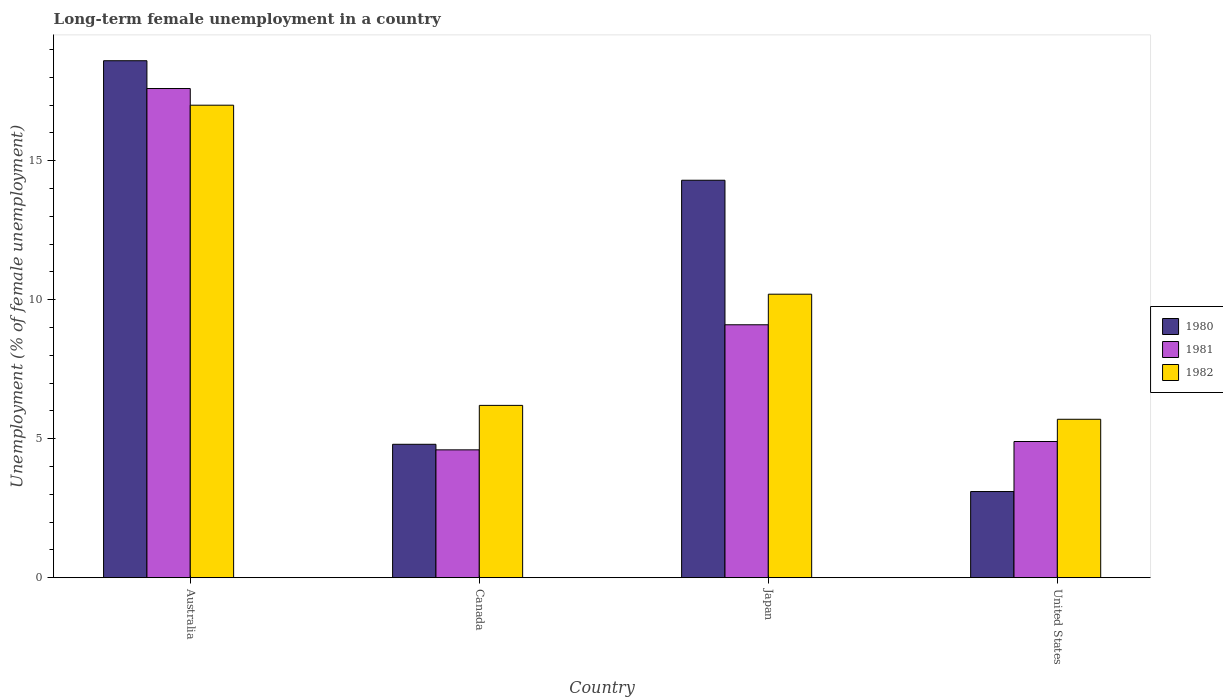How many different coloured bars are there?
Offer a terse response. 3. Are the number of bars on each tick of the X-axis equal?
Make the answer very short. Yes. How many bars are there on the 3rd tick from the right?
Offer a very short reply. 3. What is the label of the 1st group of bars from the left?
Keep it short and to the point. Australia. In how many cases, is the number of bars for a given country not equal to the number of legend labels?
Ensure brevity in your answer.  0. What is the percentage of long-term unemployed female population in 1981 in United States?
Your answer should be compact. 4.9. Across all countries, what is the maximum percentage of long-term unemployed female population in 1981?
Your answer should be very brief. 17.6. Across all countries, what is the minimum percentage of long-term unemployed female population in 1981?
Provide a succinct answer. 4.6. In which country was the percentage of long-term unemployed female population in 1982 minimum?
Your response must be concise. United States. What is the total percentage of long-term unemployed female population in 1982 in the graph?
Give a very brief answer. 39.1. What is the difference between the percentage of long-term unemployed female population in 1982 in Australia and that in Canada?
Your answer should be very brief. 10.8. What is the difference between the percentage of long-term unemployed female population in 1981 in United States and the percentage of long-term unemployed female population in 1982 in Canada?
Offer a very short reply. -1.3. What is the average percentage of long-term unemployed female population in 1980 per country?
Make the answer very short. 10.2. What is the difference between the percentage of long-term unemployed female population of/in 1982 and percentage of long-term unemployed female population of/in 1981 in Japan?
Your response must be concise. 1.1. What is the ratio of the percentage of long-term unemployed female population in 1981 in Canada to that in Japan?
Offer a very short reply. 0.51. Is the difference between the percentage of long-term unemployed female population in 1982 in Canada and United States greater than the difference between the percentage of long-term unemployed female population in 1981 in Canada and United States?
Keep it short and to the point. Yes. What is the difference between the highest and the second highest percentage of long-term unemployed female population in 1982?
Offer a very short reply. 6.8. What is the difference between the highest and the lowest percentage of long-term unemployed female population in 1982?
Offer a very short reply. 11.3. In how many countries, is the percentage of long-term unemployed female population in 1982 greater than the average percentage of long-term unemployed female population in 1982 taken over all countries?
Ensure brevity in your answer.  2. What does the 2nd bar from the left in Australia represents?
Make the answer very short. 1981. What does the 2nd bar from the right in United States represents?
Offer a terse response. 1981. How many bars are there?
Your response must be concise. 12. Does the graph contain grids?
Ensure brevity in your answer.  No. How many legend labels are there?
Your response must be concise. 3. What is the title of the graph?
Give a very brief answer. Long-term female unemployment in a country. What is the label or title of the Y-axis?
Ensure brevity in your answer.  Unemployment (% of female unemployment). What is the Unemployment (% of female unemployment) in 1980 in Australia?
Offer a terse response. 18.6. What is the Unemployment (% of female unemployment) of 1981 in Australia?
Make the answer very short. 17.6. What is the Unemployment (% of female unemployment) in 1982 in Australia?
Keep it short and to the point. 17. What is the Unemployment (% of female unemployment) of 1980 in Canada?
Your response must be concise. 4.8. What is the Unemployment (% of female unemployment) of 1981 in Canada?
Offer a terse response. 4.6. What is the Unemployment (% of female unemployment) of 1982 in Canada?
Your answer should be very brief. 6.2. What is the Unemployment (% of female unemployment) in 1980 in Japan?
Keep it short and to the point. 14.3. What is the Unemployment (% of female unemployment) in 1981 in Japan?
Make the answer very short. 9.1. What is the Unemployment (% of female unemployment) in 1982 in Japan?
Offer a very short reply. 10.2. What is the Unemployment (% of female unemployment) of 1980 in United States?
Your answer should be compact. 3.1. What is the Unemployment (% of female unemployment) in 1981 in United States?
Your answer should be compact. 4.9. What is the Unemployment (% of female unemployment) of 1982 in United States?
Your response must be concise. 5.7. Across all countries, what is the maximum Unemployment (% of female unemployment) in 1980?
Your answer should be very brief. 18.6. Across all countries, what is the maximum Unemployment (% of female unemployment) in 1981?
Your answer should be compact. 17.6. Across all countries, what is the maximum Unemployment (% of female unemployment) of 1982?
Offer a terse response. 17. Across all countries, what is the minimum Unemployment (% of female unemployment) in 1980?
Make the answer very short. 3.1. Across all countries, what is the minimum Unemployment (% of female unemployment) of 1981?
Make the answer very short. 4.6. Across all countries, what is the minimum Unemployment (% of female unemployment) of 1982?
Make the answer very short. 5.7. What is the total Unemployment (% of female unemployment) of 1980 in the graph?
Your answer should be compact. 40.8. What is the total Unemployment (% of female unemployment) in 1981 in the graph?
Your answer should be compact. 36.2. What is the total Unemployment (% of female unemployment) in 1982 in the graph?
Make the answer very short. 39.1. What is the difference between the Unemployment (% of female unemployment) of 1982 in Australia and that in Canada?
Your response must be concise. 10.8. What is the difference between the Unemployment (% of female unemployment) of 1980 in Australia and that in Japan?
Offer a very short reply. 4.3. What is the difference between the Unemployment (% of female unemployment) in 1981 in Australia and that in Japan?
Your response must be concise. 8.5. What is the difference between the Unemployment (% of female unemployment) in 1982 in Australia and that in Japan?
Provide a succinct answer. 6.8. What is the difference between the Unemployment (% of female unemployment) of 1980 in Australia and that in United States?
Your answer should be very brief. 15.5. What is the difference between the Unemployment (% of female unemployment) in 1981 in Australia and that in United States?
Give a very brief answer. 12.7. What is the difference between the Unemployment (% of female unemployment) in 1980 in Canada and that in Japan?
Keep it short and to the point. -9.5. What is the difference between the Unemployment (% of female unemployment) in 1981 in Canada and that in Japan?
Ensure brevity in your answer.  -4.5. What is the difference between the Unemployment (% of female unemployment) in 1981 in Japan and that in United States?
Give a very brief answer. 4.2. What is the difference between the Unemployment (% of female unemployment) of 1982 in Japan and that in United States?
Give a very brief answer. 4.5. What is the difference between the Unemployment (% of female unemployment) in 1980 in Australia and the Unemployment (% of female unemployment) in 1982 in United States?
Provide a short and direct response. 12.9. What is the difference between the Unemployment (% of female unemployment) in 1981 in Canada and the Unemployment (% of female unemployment) in 1982 in United States?
Give a very brief answer. -1.1. What is the difference between the Unemployment (% of female unemployment) of 1980 in Japan and the Unemployment (% of female unemployment) of 1981 in United States?
Your answer should be very brief. 9.4. What is the difference between the Unemployment (% of female unemployment) in 1981 in Japan and the Unemployment (% of female unemployment) in 1982 in United States?
Your answer should be compact. 3.4. What is the average Unemployment (% of female unemployment) in 1980 per country?
Provide a short and direct response. 10.2. What is the average Unemployment (% of female unemployment) of 1981 per country?
Provide a succinct answer. 9.05. What is the average Unemployment (% of female unemployment) of 1982 per country?
Ensure brevity in your answer.  9.78. What is the difference between the Unemployment (% of female unemployment) in 1980 and Unemployment (% of female unemployment) in 1982 in Japan?
Your response must be concise. 4.1. What is the difference between the Unemployment (% of female unemployment) of 1981 and Unemployment (% of female unemployment) of 1982 in Japan?
Your response must be concise. -1.1. What is the difference between the Unemployment (% of female unemployment) in 1980 and Unemployment (% of female unemployment) in 1981 in United States?
Make the answer very short. -1.8. What is the ratio of the Unemployment (% of female unemployment) of 1980 in Australia to that in Canada?
Give a very brief answer. 3.88. What is the ratio of the Unemployment (% of female unemployment) in 1981 in Australia to that in Canada?
Provide a succinct answer. 3.83. What is the ratio of the Unemployment (% of female unemployment) in 1982 in Australia to that in Canada?
Make the answer very short. 2.74. What is the ratio of the Unemployment (% of female unemployment) in 1980 in Australia to that in Japan?
Your answer should be compact. 1.3. What is the ratio of the Unemployment (% of female unemployment) in 1981 in Australia to that in Japan?
Your answer should be very brief. 1.93. What is the ratio of the Unemployment (% of female unemployment) of 1981 in Australia to that in United States?
Offer a very short reply. 3.59. What is the ratio of the Unemployment (% of female unemployment) of 1982 in Australia to that in United States?
Your answer should be compact. 2.98. What is the ratio of the Unemployment (% of female unemployment) of 1980 in Canada to that in Japan?
Provide a succinct answer. 0.34. What is the ratio of the Unemployment (% of female unemployment) of 1981 in Canada to that in Japan?
Provide a short and direct response. 0.51. What is the ratio of the Unemployment (% of female unemployment) in 1982 in Canada to that in Japan?
Provide a succinct answer. 0.61. What is the ratio of the Unemployment (% of female unemployment) in 1980 in Canada to that in United States?
Give a very brief answer. 1.55. What is the ratio of the Unemployment (% of female unemployment) of 1981 in Canada to that in United States?
Offer a terse response. 0.94. What is the ratio of the Unemployment (% of female unemployment) of 1982 in Canada to that in United States?
Give a very brief answer. 1.09. What is the ratio of the Unemployment (% of female unemployment) of 1980 in Japan to that in United States?
Provide a short and direct response. 4.61. What is the ratio of the Unemployment (% of female unemployment) in 1981 in Japan to that in United States?
Offer a terse response. 1.86. What is the ratio of the Unemployment (% of female unemployment) in 1982 in Japan to that in United States?
Provide a succinct answer. 1.79. What is the difference between the highest and the second highest Unemployment (% of female unemployment) in 1982?
Your answer should be compact. 6.8. 